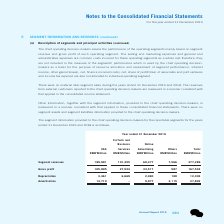According to Tencent's financial document, How much is the VAS segment revenue? According to the financial document, 199,991 (in millions). The relevant text states: "Segment revenues 199,991 101,355 68,377 7,566 377,289..." Also, How much is the VAS gross profit? According to the financial document, 105,905 (in millions). The relevant text states: "Gross profit 105,905 27,524 33,517 587 167,533..." Also, How much is the VAS depreciation? According to the financial document, 3,461 (in millions). The relevant text states: "Depreciation 3,461 6,669 2,065 108 12,303..." Also, can you calculate: How many percent of total segment revenues is the VAS segment revenue?  Based on the calculation: 199,991/377,289, the result is 53.01 (percentage). This is based on the information: "Segment revenues 199,991 101,355 68,377 7,566 377,289 Segment revenues 199,991 101,355 68,377 7,566 377,289..." The key data points involved are: 199,991, 377,289. Also, can you calculate: How many percent of total depreciation was the VAS depreciation? Based on the calculation: 3,461/12,303, the result is 28.13 (percentage). This is based on the information: "Depreciation 3,461 6,669 2,065 108 12,303 Depreciation 3,461 6,669 2,065 108 12,303..." The key data points involved are: 12,303, 3,461. Also, can you calculate: How many percent of total amortisation was the VAS amortisation? Based on the calculation: 14,710/27,802, the result is 52.91 (percentage). This is based on the information: "Amortisation 14,710 – 9,977 3,115 27,802 Amortisation 14,710 – 9,977 3,115 27,802..." The key data points involved are: 14,710, 27,802. 